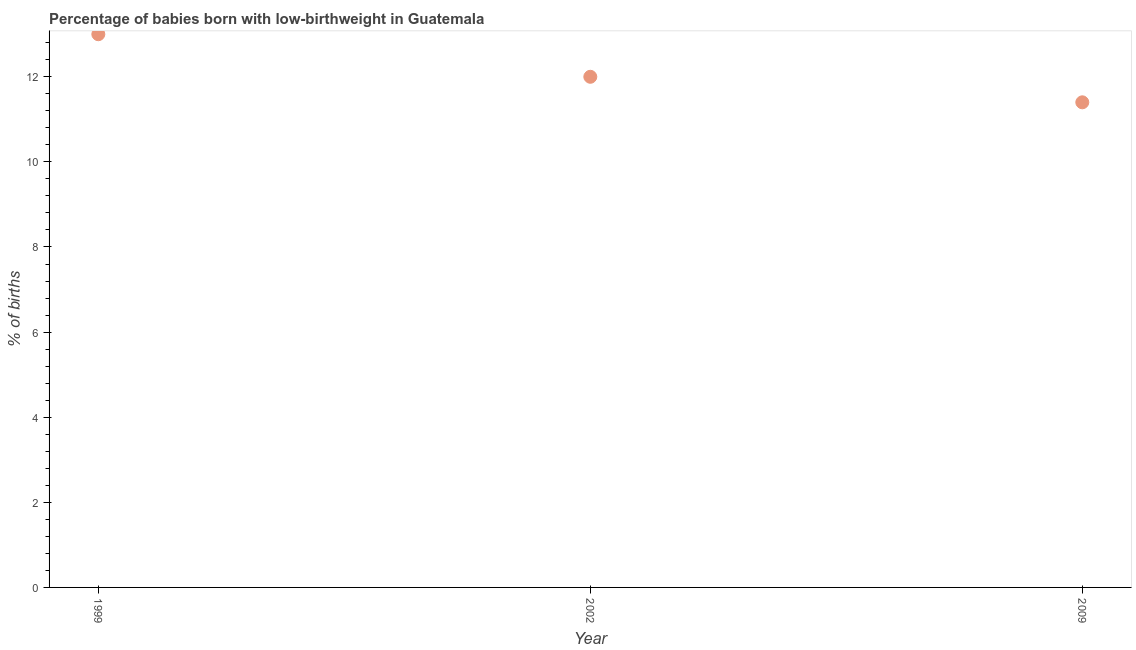What is the percentage of babies who were born with low-birthweight in 1999?
Keep it short and to the point. 13. Across all years, what is the maximum percentage of babies who were born with low-birthweight?
Offer a very short reply. 13. What is the sum of the percentage of babies who were born with low-birthweight?
Keep it short and to the point. 36.4. What is the difference between the percentage of babies who were born with low-birthweight in 1999 and 2009?
Provide a short and direct response. 1.6. What is the average percentage of babies who were born with low-birthweight per year?
Provide a succinct answer. 12.13. In how many years, is the percentage of babies who were born with low-birthweight greater than 12.4 %?
Offer a very short reply. 1. Do a majority of the years between 1999 and 2002 (inclusive) have percentage of babies who were born with low-birthweight greater than 9.2 %?
Your response must be concise. Yes. What is the ratio of the percentage of babies who were born with low-birthweight in 1999 to that in 2002?
Your answer should be very brief. 1.08. Is the percentage of babies who were born with low-birthweight in 1999 less than that in 2002?
Give a very brief answer. No. What is the difference between the highest and the lowest percentage of babies who were born with low-birthweight?
Offer a very short reply. 1.6. In how many years, is the percentage of babies who were born with low-birthweight greater than the average percentage of babies who were born with low-birthweight taken over all years?
Provide a succinct answer. 1. Does the percentage of babies who were born with low-birthweight monotonically increase over the years?
Your answer should be compact. No. How many dotlines are there?
Provide a succinct answer. 1. Are the values on the major ticks of Y-axis written in scientific E-notation?
Make the answer very short. No. Does the graph contain grids?
Your answer should be compact. No. What is the title of the graph?
Offer a terse response. Percentage of babies born with low-birthweight in Guatemala. What is the label or title of the Y-axis?
Provide a short and direct response. % of births. What is the % of births in 2002?
Your answer should be compact. 12. What is the % of births in 2009?
Offer a terse response. 11.4. What is the ratio of the % of births in 1999 to that in 2002?
Keep it short and to the point. 1.08. What is the ratio of the % of births in 1999 to that in 2009?
Provide a short and direct response. 1.14. What is the ratio of the % of births in 2002 to that in 2009?
Your response must be concise. 1.05. 